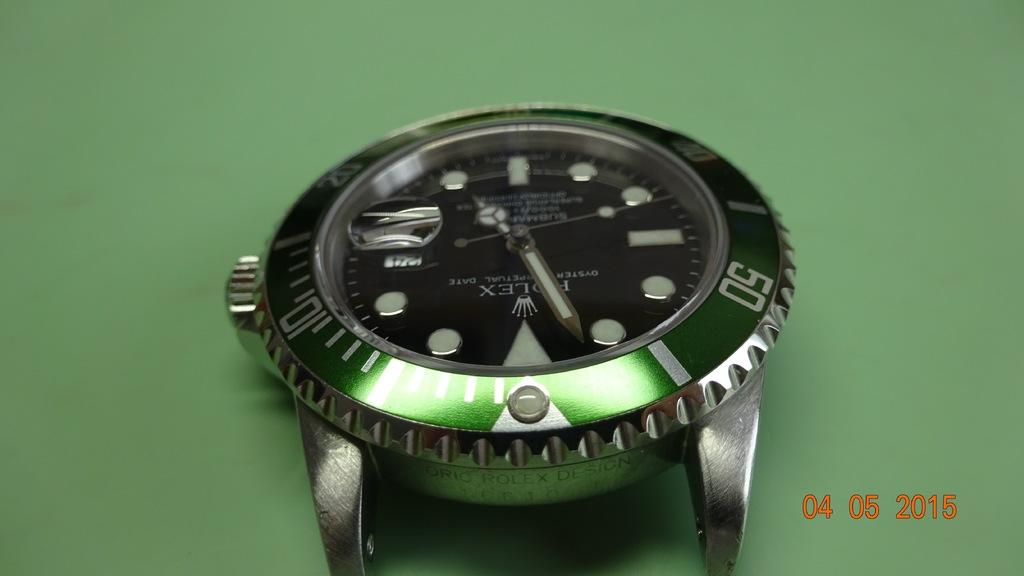Provide a one-sentence caption for the provided image. A watch lies on its back with no strap and tells the time as almost 5 o'clock. 